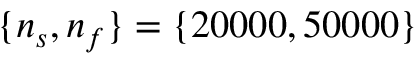Convert formula to latex. <formula><loc_0><loc_0><loc_500><loc_500>\{ n _ { s } , n _ { f } \} = \{ 2 0 0 0 0 , 5 0 0 0 0 \}</formula> 